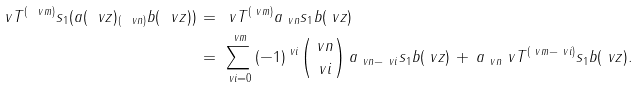Convert formula to latex. <formula><loc_0><loc_0><loc_500><loc_500>\ v T ^ { ( \ v m ) } s _ { 1 } ( a ( \ v z ) _ { ( \ v n ) } b ( \ v z ) ) \, & = \, \ v T ^ { ( \ v m ) } a _ { \ v n } s _ { 1 } b ( \ v z ) \\ & = \, \sum _ { \ v i = 0 } ^ { \ v m } \, ( - 1 ) ^ { \ v i } \binom { \ v n } { \ v i } \, a _ { \ v n - \ v i } s _ { 1 } b ( \ v z ) \, + \, a _ { \ v n } \ v T ^ { ( \ v m - \ v i ) } s _ { 1 } b ( \ v z ) .</formula> 